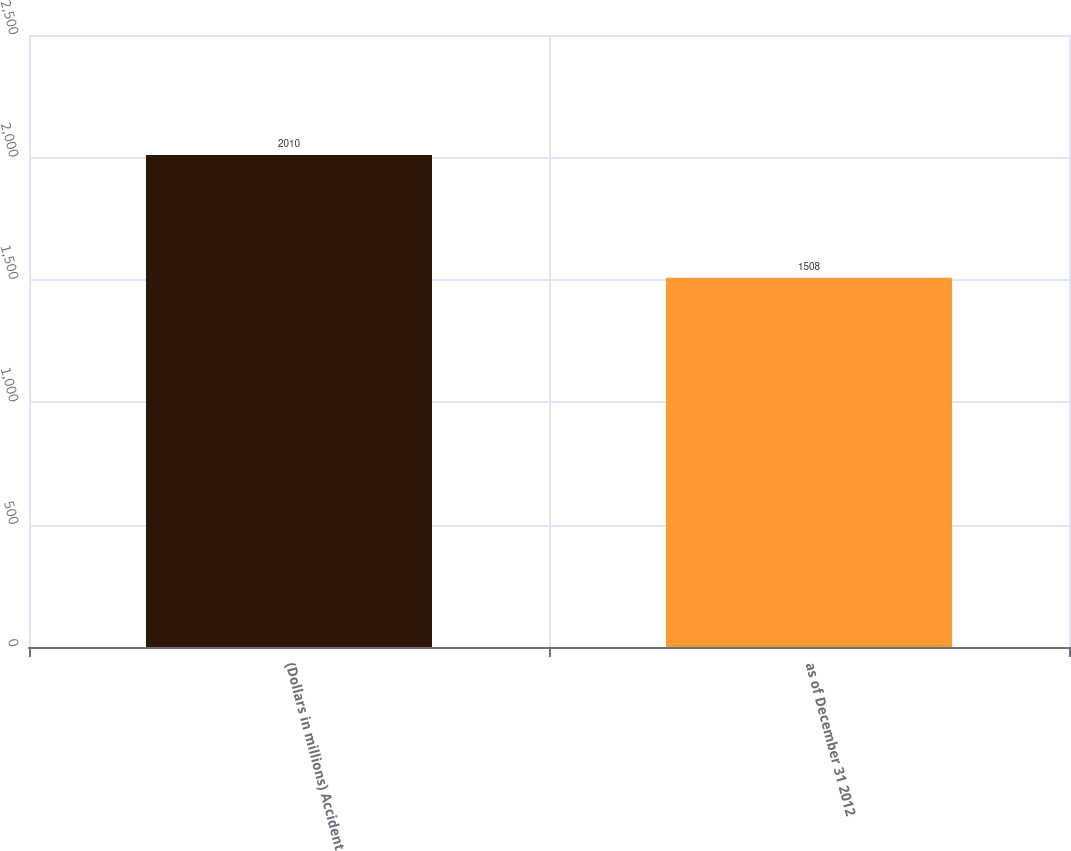Convert chart to OTSL. <chart><loc_0><loc_0><loc_500><loc_500><bar_chart><fcel>(Dollars in millions) Accident<fcel>as of December 31 2012<nl><fcel>2010<fcel>1508<nl></chart> 